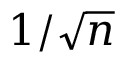Convert formula to latex. <formula><loc_0><loc_0><loc_500><loc_500>1 / { \sqrt { n } }</formula> 